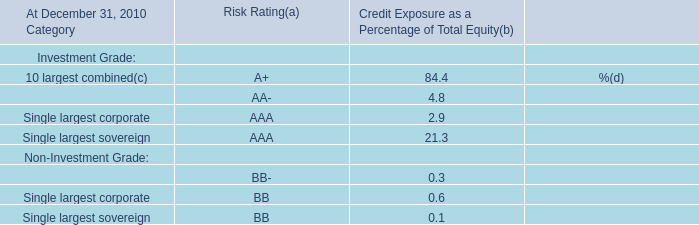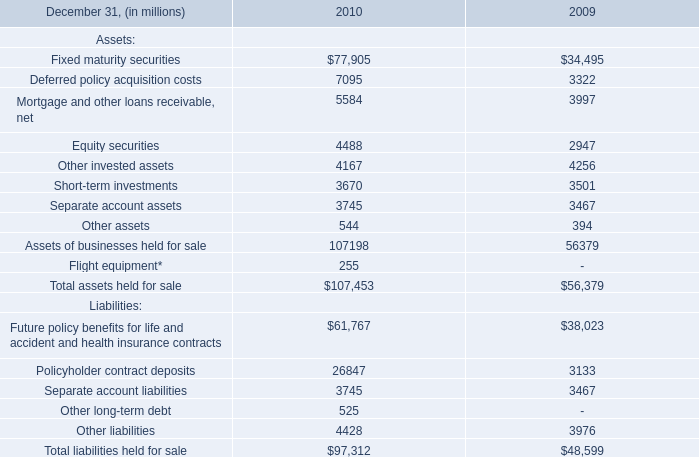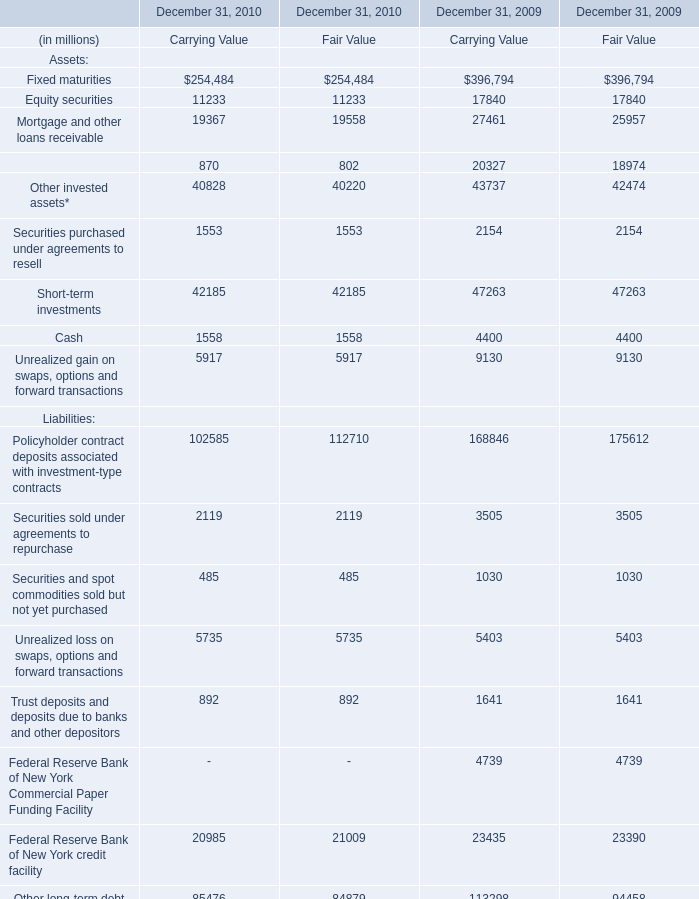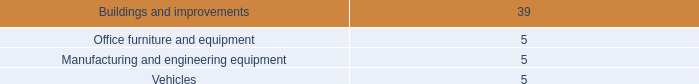considering the year 2007 , how many shares belonged to the shareholders? 
Computations: (162531 / 0.75)
Answer: 216708.0. 